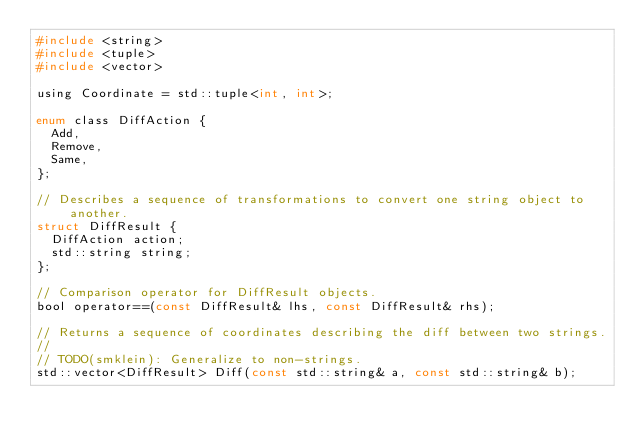<code> <loc_0><loc_0><loc_500><loc_500><_C_>#include <string>
#include <tuple>
#include <vector>

using Coordinate = std::tuple<int, int>;

enum class DiffAction {
  Add,
  Remove,
  Same,
};

// Describes a sequence of transformations to convert one string object to another.
struct DiffResult {
  DiffAction action;
  std::string string;
};

// Comparison operator for DiffResult objects.
bool operator==(const DiffResult& lhs, const DiffResult& rhs);

// Returns a sequence of coordinates describing the diff between two strings.
//
// TODO(smklein): Generalize to non-strings.
std::vector<DiffResult> Diff(const std::string& a, const std::string& b);
</code> 